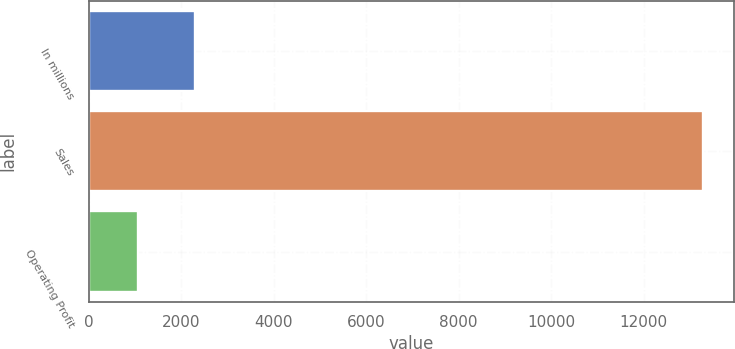Convert chart. <chart><loc_0><loc_0><loc_500><loc_500><bar_chart><fcel>In millions<fcel>Sales<fcel>Operating Profit<nl><fcel>2287.4<fcel>13280<fcel>1066<nl></chart> 